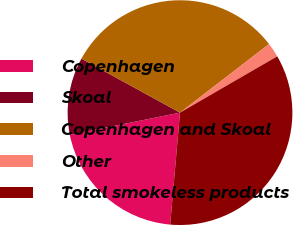Convert chart to OTSL. <chart><loc_0><loc_0><loc_500><loc_500><pie_chart><fcel>Copenhagen<fcel>Skoal<fcel>Copenhagen and Skoal<fcel>Other<fcel>Total smokeless products<nl><fcel>20.44%<fcel>11.14%<fcel>31.58%<fcel>2.09%<fcel>34.74%<nl></chart> 